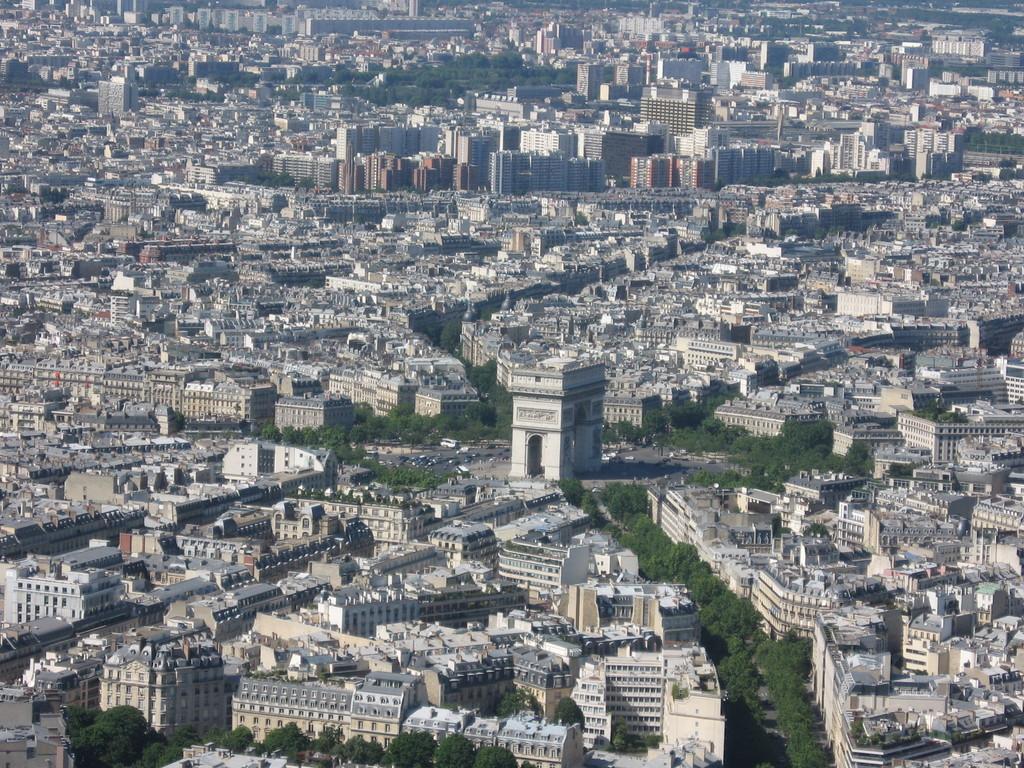How would you summarize this image in a sentence or two? This is an aerial view. In this image we can see buildings, skyscrapers, trees and roads. 